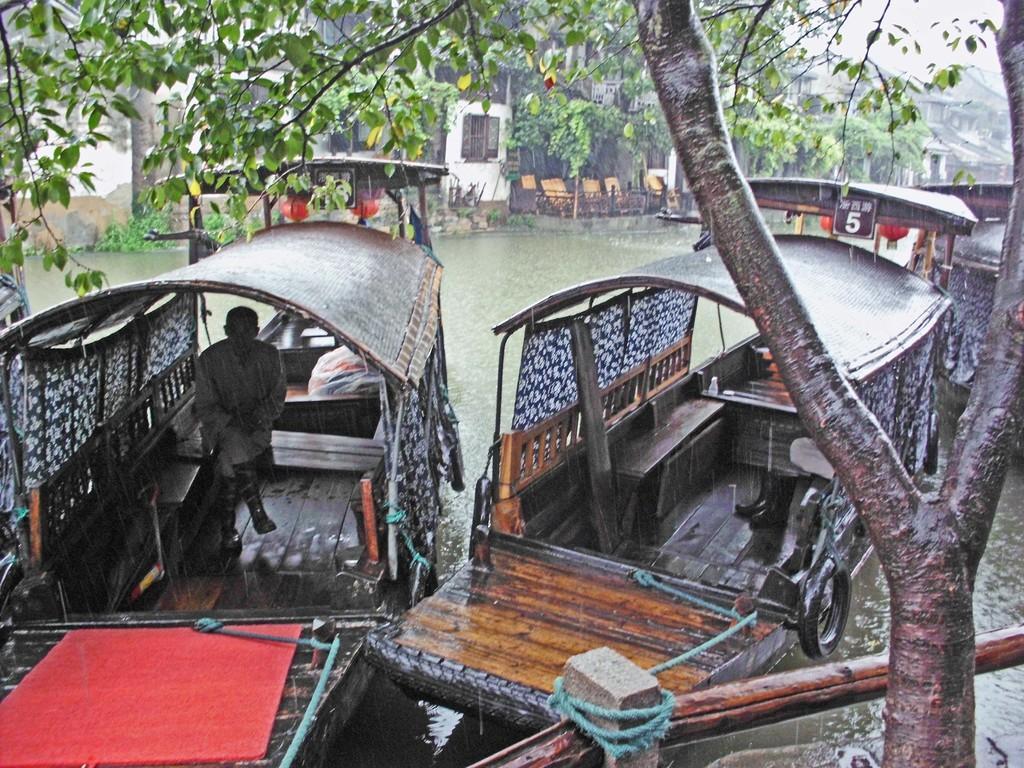Can you describe this image briefly? In this picture I can see couple of boats in the water and I can see buildings, trees and few chairs and a man seated in the boat. Looks like it is raining 